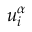<formula> <loc_0><loc_0><loc_500><loc_500>u _ { i } ^ { \alpha }</formula> 